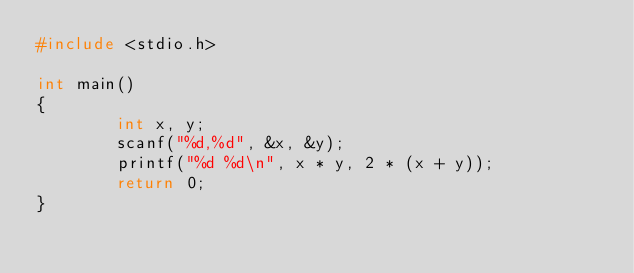Convert code to text. <code><loc_0><loc_0><loc_500><loc_500><_C_>#include <stdio.h>
 
int main()
{
        int x, y;
        scanf("%d,%d", &x, &y);
        printf("%d %d\n", x * y, 2 * (x + y));
        return 0;
}</code> 